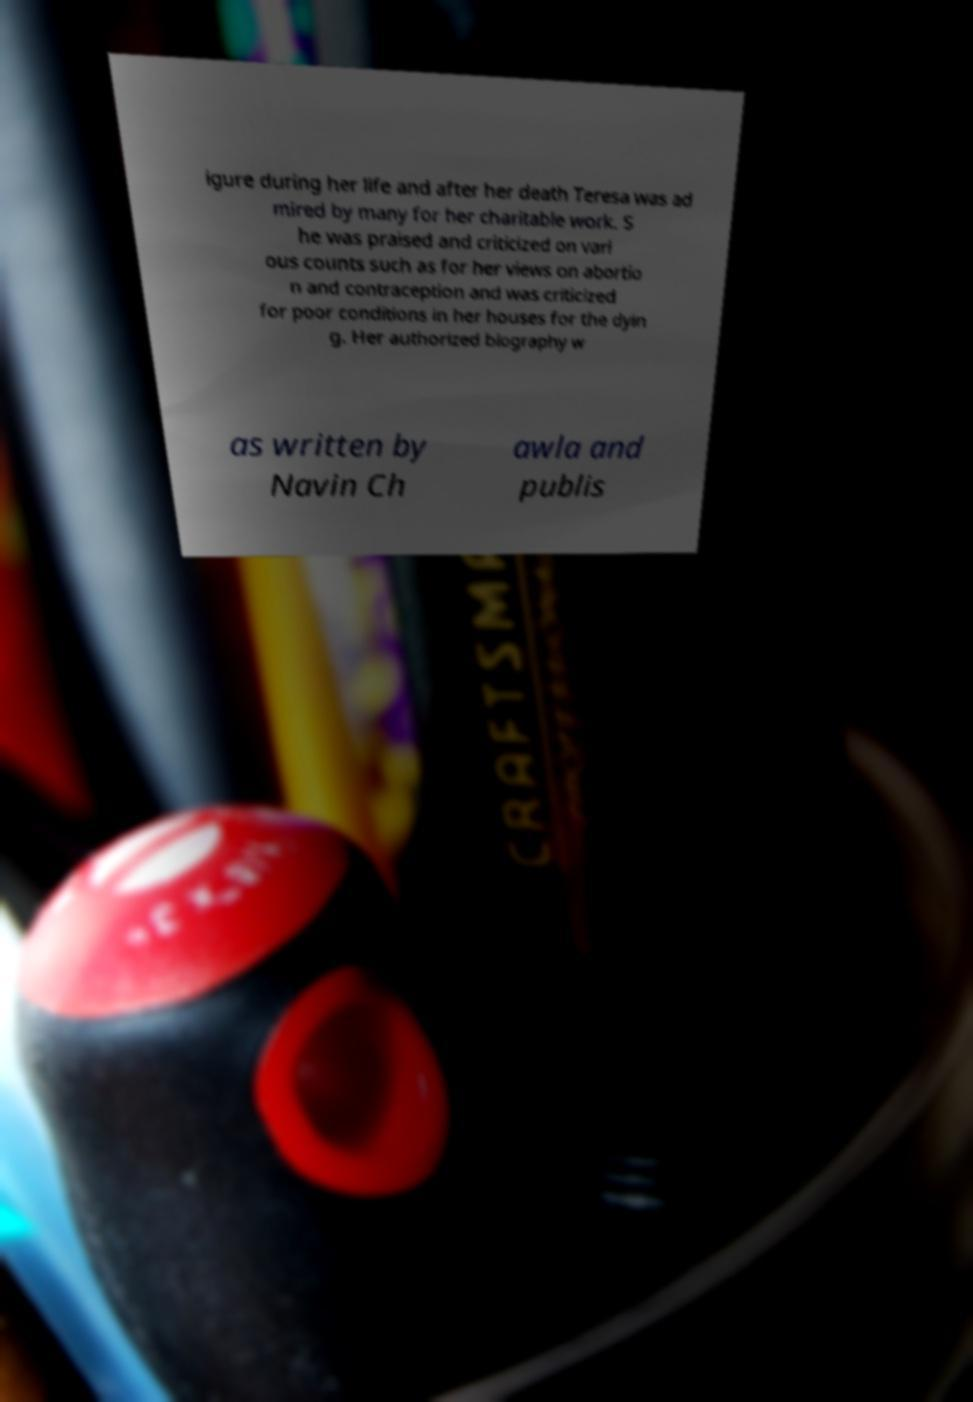For documentation purposes, I need the text within this image transcribed. Could you provide that? igure during her life and after her death Teresa was ad mired by many for her charitable work. S he was praised and criticized on vari ous counts such as for her views on abortio n and contraception and was criticized for poor conditions in her houses for the dyin g. Her authorized biography w as written by Navin Ch awla and publis 